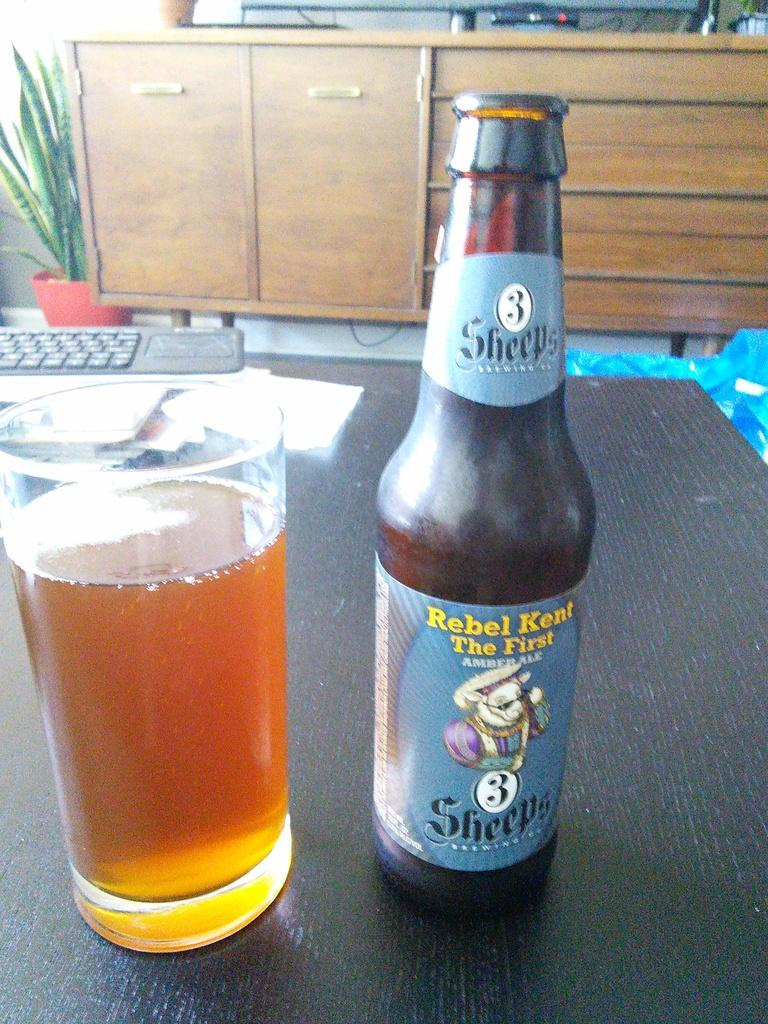Provide a one-sentence caption for the provided image. A bottle of Rebel Kent Amber Ale next to a glass of the ale on a table. 